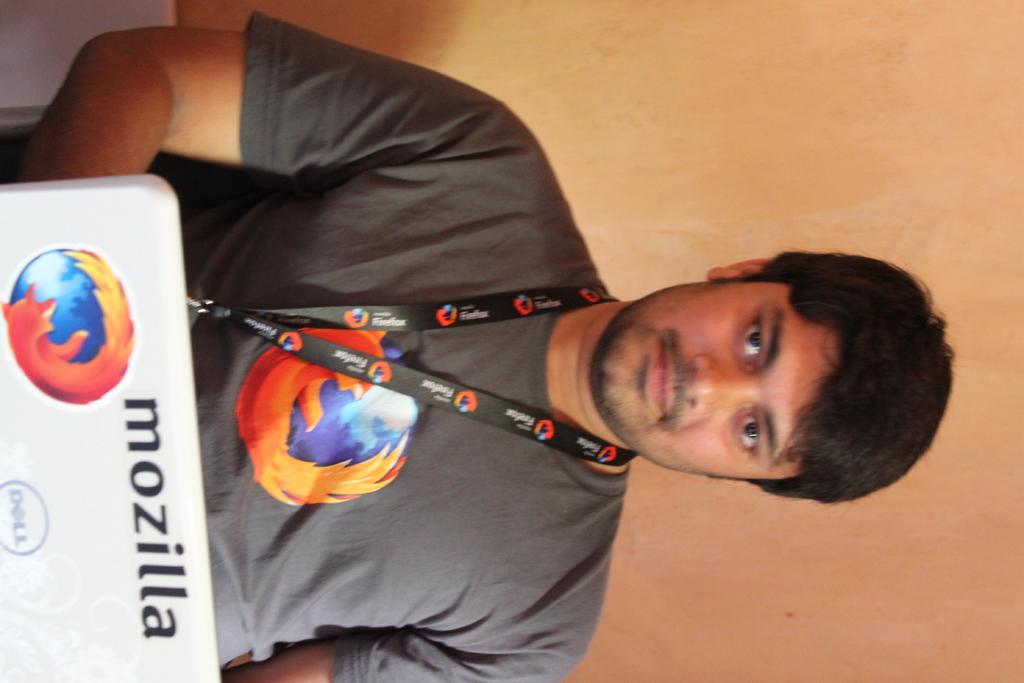What is the color of the wall in the image? There is an orange color wall in the image. What else can be seen hanging on the wall? There is a banner in the image. Who is present in the image? There is a man in the image. What is the man wearing that matches the color of the wall? The man is wearing an orange color t-shirt. Can you hear the man whistling in the image? There is no indication of sound or whistling in the image; it is a still photograph. 